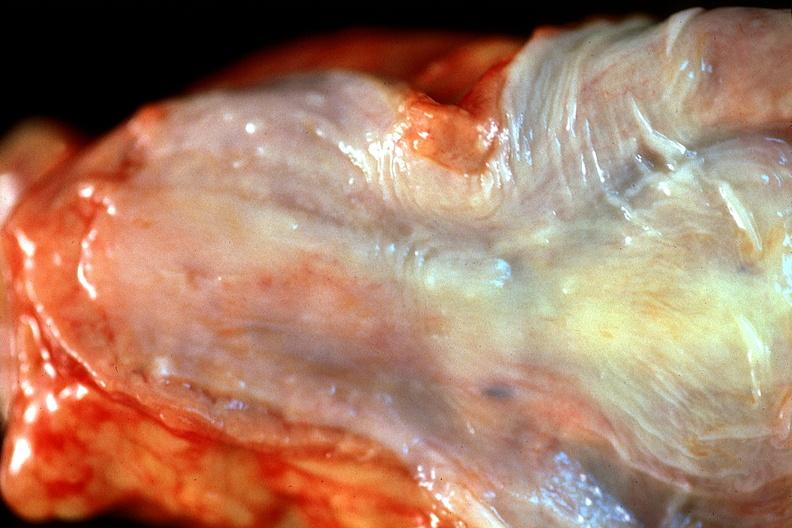does this image show normal esophagus?
Answer the question using a single word or phrase. Yes 